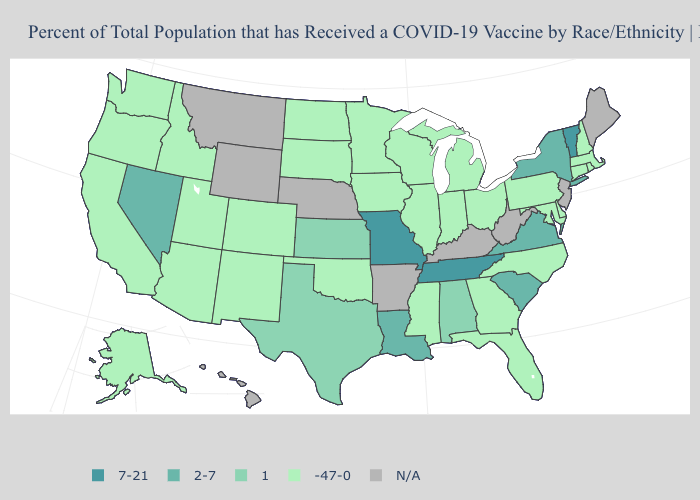How many symbols are there in the legend?
Keep it brief. 5. Which states have the lowest value in the USA?
Quick response, please. Alaska, Arizona, California, Colorado, Connecticut, Delaware, Florida, Georgia, Idaho, Illinois, Indiana, Iowa, Maryland, Massachusetts, Michigan, Minnesota, Mississippi, New Hampshire, New Mexico, North Carolina, North Dakota, Ohio, Oklahoma, Oregon, Pennsylvania, Rhode Island, South Dakota, Utah, Washington, Wisconsin. What is the lowest value in states that border Montana?
Concise answer only. -47-0. What is the value of Louisiana?
Quick response, please. 2-7. Does the map have missing data?
Answer briefly. Yes. What is the highest value in the USA?
Concise answer only. 7-21. Does Oklahoma have the lowest value in the USA?
Quick response, please. Yes. Among the states that border Tennessee , does Missouri have the lowest value?
Short answer required. No. Name the states that have a value in the range -47-0?
Short answer required. Alaska, Arizona, California, Colorado, Connecticut, Delaware, Florida, Georgia, Idaho, Illinois, Indiana, Iowa, Maryland, Massachusetts, Michigan, Minnesota, Mississippi, New Hampshire, New Mexico, North Carolina, North Dakota, Ohio, Oklahoma, Oregon, Pennsylvania, Rhode Island, South Dakota, Utah, Washington, Wisconsin. Name the states that have a value in the range N/A?
Give a very brief answer. Arkansas, Hawaii, Kentucky, Maine, Montana, Nebraska, New Jersey, West Virginia, Wyoming. What is the value of Kansas?
Answer briefly. 1. Does the map have missing data?
Quick response, please. Yes. What is the value of Indiana?
Short answer required. -47-0. What is the highest value in the USA?
Write a very short answer. 7-21. What is the value of Oklahoma?
Be succinct. -47-0. 